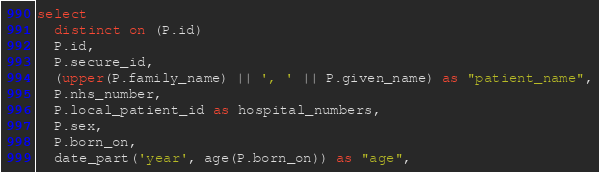<code> <loc_0><loc_0><loc_500><loc_500><_SQL_>select
  distinct on (P.id)
  P.id,
  P.secure_id,
  (upper(P.family_name) || ', ' || P.given_name) as "patient_name",
  P.nhs_number,
  P.local_patient_id as hospital_numbers,
  P.sex,
  P.born_on,
  date_part('year', age(P.born_on)) as "age",</code> 